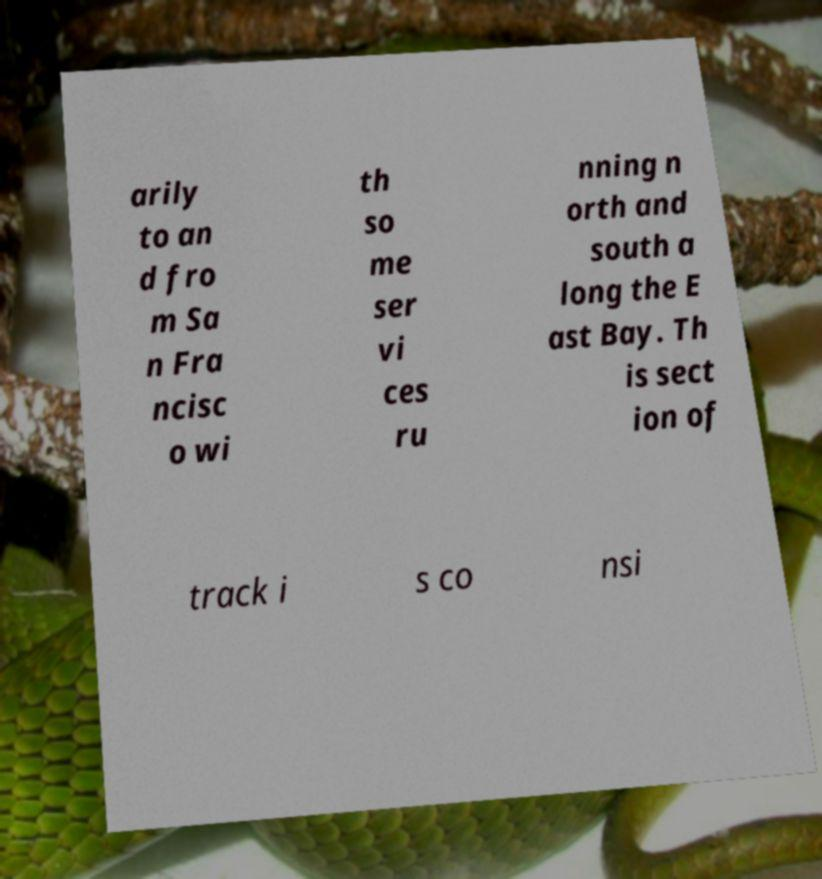Can you read and provide the text displayed in the image?This photo seems to have some interesting text. Can you extract and type it out for me? arily to an d fro m Sa n Fra ncisc o wi th so me ser vi ces ru nning n orth and south a long the E ast Bay. Th is sect ion of track i s co nsi 